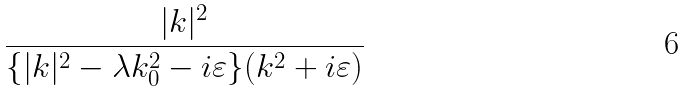Convert formula to latex. <formula><loc_0><loc_0><loc_500><loc_500>\frac { | k | ^ { 2 } } { \{ | k | ^ { 2 } - \lambda k _ { 0 } ^ { 2 } - i \varepsilon \} ( k ^ { 2 } + i \varepsilon ) }</formula> 